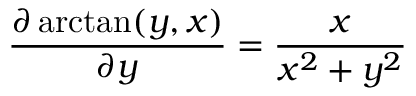<formula> <loc_0><loc_0><loc_500><loc_500>{ \frac { \partial \arctan ( y , x ) } { \partial y } } = { \frac { x } { x ^ { 2 } + y ^ { 2 } } }</formula> 